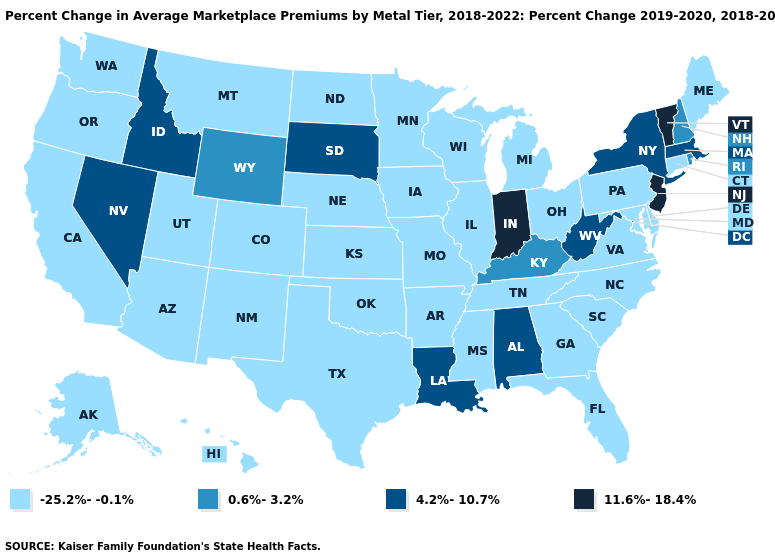What is the highest value in states that border New Mexico?
Give a very brief answer. -25.2%--0.1%. Name the states that have a value in the range -25.2%--0.1%?
Be succinct. Alaska, Arizona, Arkansas, California, Colorado, Connecticut, Delaware, Florida, Georgia, Hawaii, Illinois, Iowa, Kansas, Maine, Maryland, Michigan, Minnesota, Mississippi, Missouri, Montana, Nebraska, New Mexico, North Carolina, North Dakota, Ohio, Oklahoma, Oregon, Pennsylvania, South Carolina, Tennessee, Texas, Utah, Virginia, Washington, Wisconsin. What is the value of Nevada?
Concise answer only. 4.2%-10.7%. Does Georgia have the highest value in the USA?
Quick response, please. No. What is the value of Maryland?
Write a very short answer. -25.2%--0.1%. What is the value of Alabama?
Answer briefly. 4.2%-10.7%. Does South Carolina have the highest value in the USA?
Concise answer only. No. Does Florida have a lower value than Arizona?
Keep it brief. No. Among the states that border Washington , does Idaho have the lowest value?
Give a very brief answer. No. How many symbols are there in the legend?
Concise answer only. 4. Does Texas have a higher value than Arkansas?
Be succinct. No. Does the map have missing data?
Keep it brief. No. What is the highest value in states that border Kentucky?
Be succinct. 11.6%-18.4%. Name the states that have a value in the range -25.2%--0.1%?
Write a very short answer. Alaska, Arizona, Arkansas, California, Colorado, Connecticut, Delaware, Florida, Georgia, Hawaii, Illinois, Iowa, Kansas, Maine, Maryland, Michigan, Minnesota, Mississippi, Missouri, Montana, Nebraska, New Mexico, North Carolina, North Dakota, Ohio, Oklahoma, Oregon, Pennsylvania, South Carolina, Tennessee, Texas, Utah, Virginia, Washington, Wisconsin. 